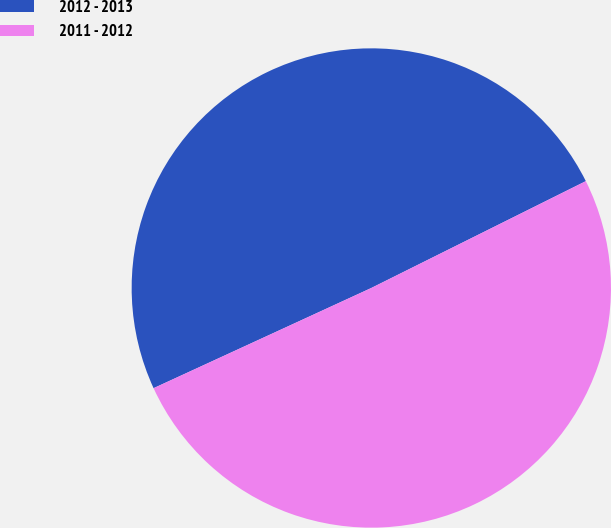<chart> <loc_0><loc_0><loc_500><loc_500><pie_chart><fcel>2012 - 2013<fcel>2011 - 2012<nl><fcel>49.51%<fcel>50.49%<nl></chart> 